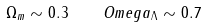Convert formula to latex. <formula><loc_0><loc_0><loc_500><loc_500>\Omega _ { m } \sim 0 . 3 \quad O m e g a _ { \Lambda } \sim 0 . 7</formula> 